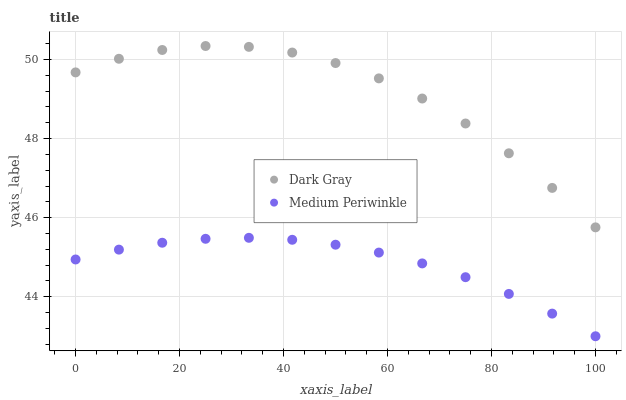Does Medium Periwinkle have the minimum area under the curve?
Answer yes or no. Yes. Does Dark Gray have the maximum area under the curve?
Answer yes or no. Yes. Does Medium Periwinkle have the maximum area under the curve?
Answer yes or no. No. Is Medium Periwinkle the smoothest?
Answer yes or no. Yes. Is Dark Gray the roughest?
Answer yes or no. Yes. Is Medium Periwinkle the roughest?
Answer yes or no. No. Does Medium Periwinkle have the lowest value?
Answer yes or no. Yes. Does Dark Gray have the highest value?
Answer yes or no. Yes. Does Medium Periwinkle have the highest value?
Answer yes or no. No. Is Medium Periwinkle less than Dark Gray?
Answer yes or no. Yes. Is Dark Gray greater than Medium Periwinkle?
Answer yes or no. Yes. Does Medium Periwinkle intersect Dark Gray?
Answer yes or no. No. 